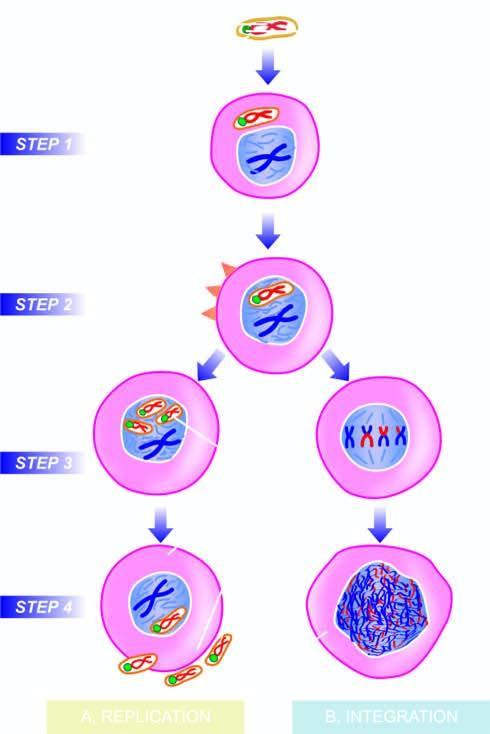s each fibril incorporated into the host nucleus?
Answer the question using a single word or phrase. No 